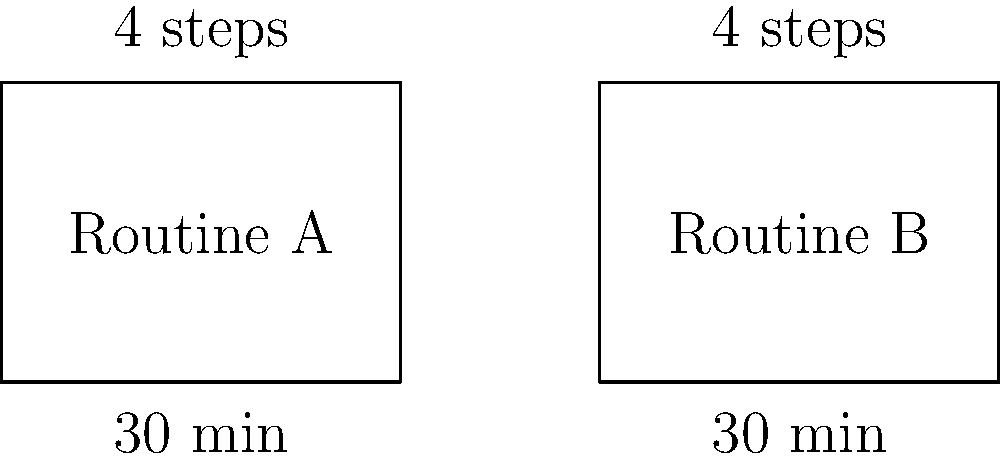As a stay-at-home parent managing household responsibilities, you're comparing two meal preparation routines. Routine A takes 30 minutes and consists of 4 steps, while Routine B also takes 30 minutes and has 4 steps. Are these two meal preparation routines congruent? To determine if the two meal preparation routines are congruent, we need to consider the definition of congruence in this context:

1. Time congruence: Both routines should take the same amount of time.
   Routine A: 30 minutes
   Routine B: 30 minutes
   The time is identical for both routines.

2. Step congruence: Both routines should have the same number of steps.
   Routine A: 4 steps
   Routine B: 4 steps
   The number of steps is identical for both routines.

3. Definition of congruence: Two figures are considered congruent if they have the same shape and size. In this context, we can consider the "shape" to be the structure of the routine (number of steps) and the "size" to be the time taken.

4. Applying the definition: Since both routines have the same number of steps (4) and take the same amount of time (30 minutes), they have the same "shape" and "size" in terms of meal preparation.

Therefore, based on this analysis, the two meal preparation routines are congruent.
Answer: Yes, congruent. 